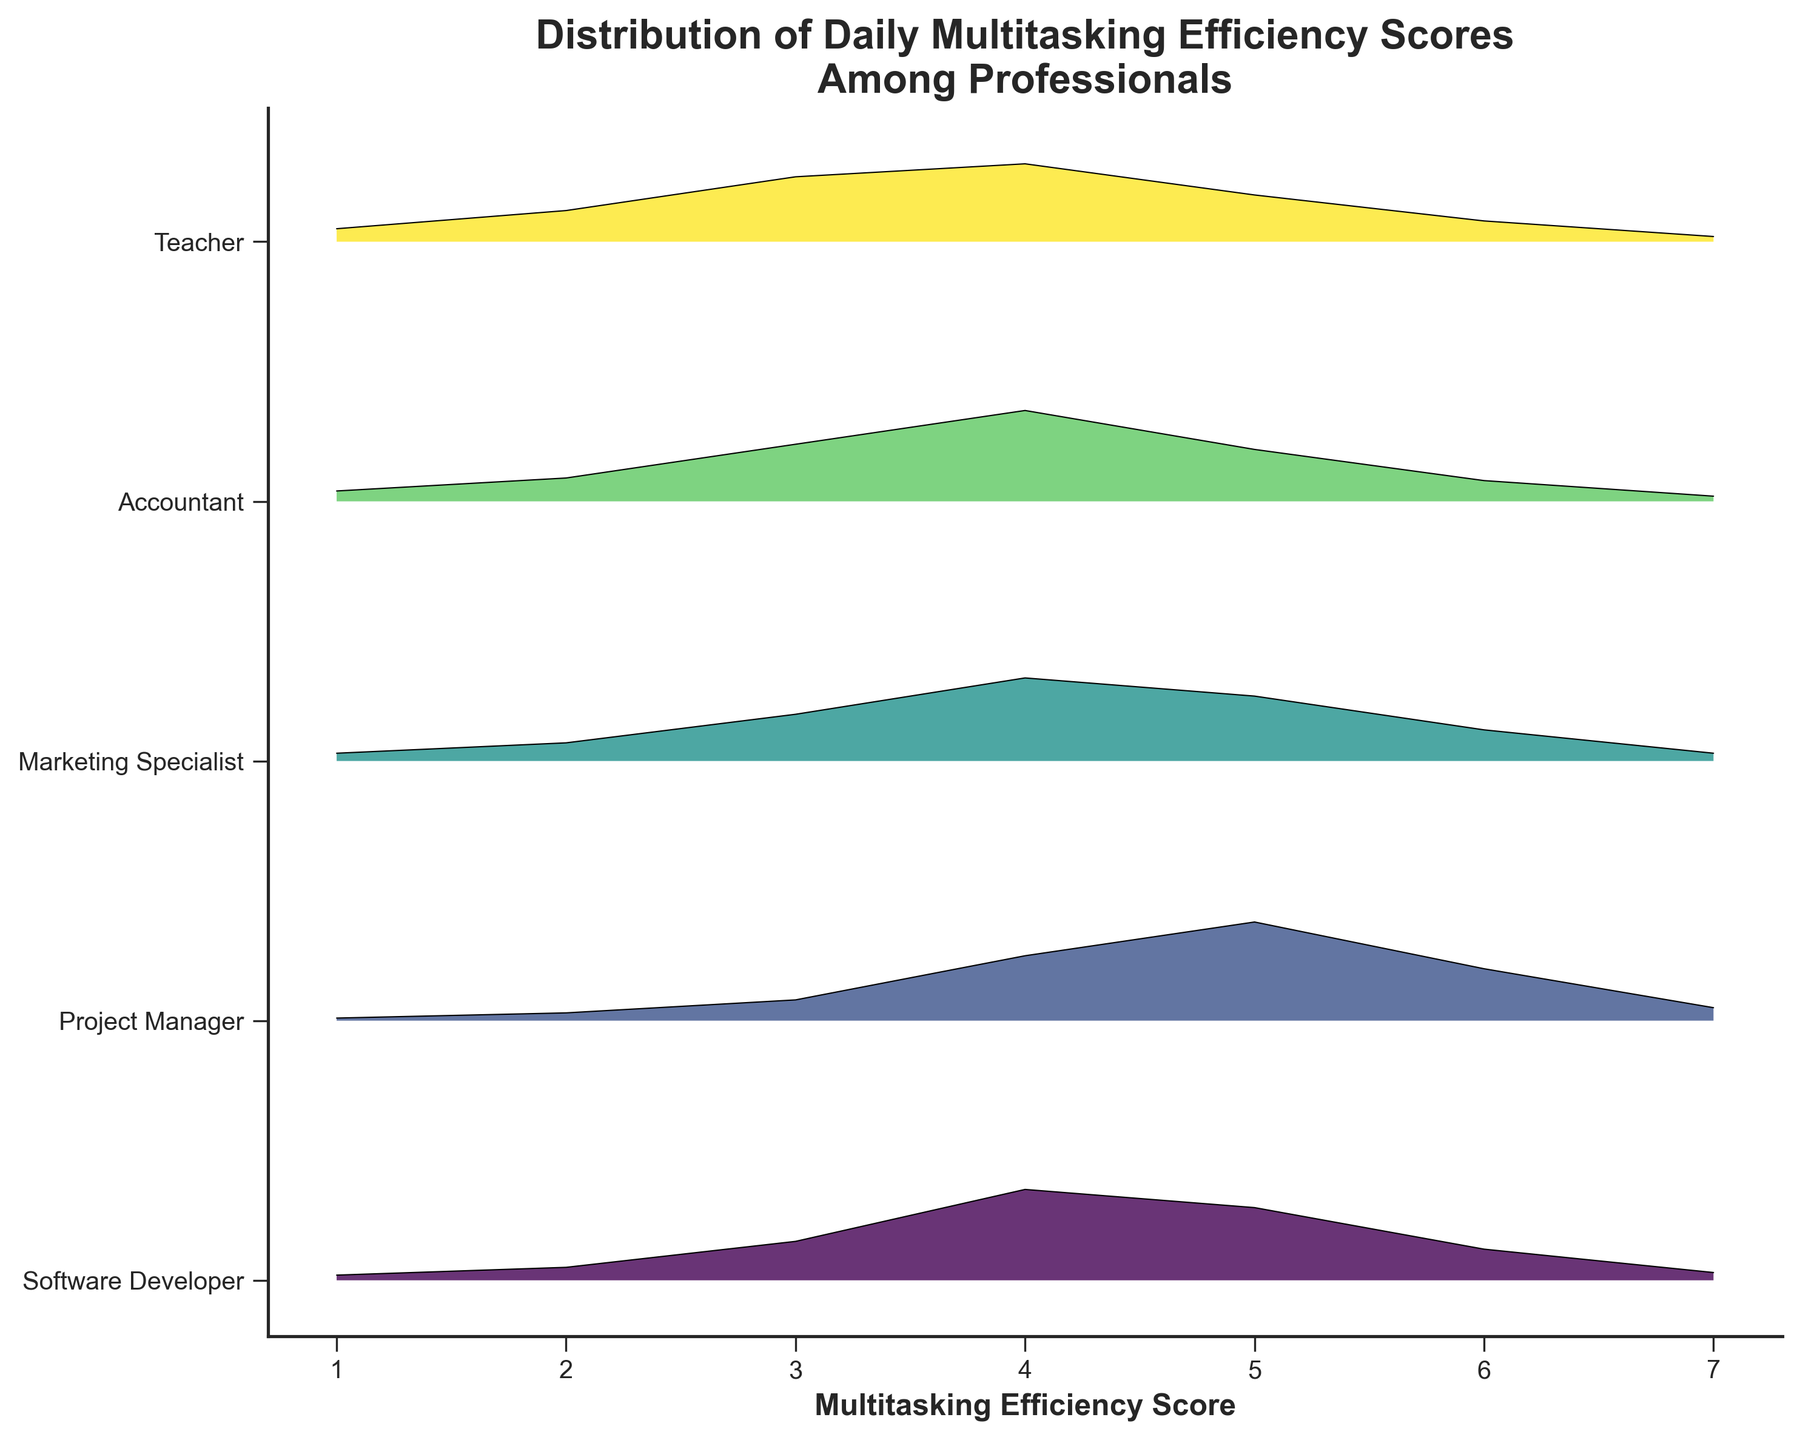What's the title of the plot? The title is located at the top of the plot and indicates what the figure is about. By reading the top area, we notice the text.
Answer: Distribution of Daily Multitasking Efficiency Scores Among Professionals What is on the x-axis of the plot? The x-axis typically shows what is being measured or the scores in this case. By looking at the label under the horizontal axis, we see the description.
Answer: Multitasking Efficiency Score How many professions are shown in the plot? By counting the distinct labels along the y-axis, we can determine the number of different professions included in the analysis.
Answer: 5 Which profession has the highest peak density in multitasking efficiency scores? To determine this, we look for the profession with the tallest peak in the plot, indicating the highest point of density.
Answer: Project Manager At which score do Teachers have their highest density? By locating the Teacher's profile in the plot and identifying the highest point of the ridgeline for that profile, we find the multitasking efficiency score corresponding to this peak.
Answer: 3 Which profession has the widest distribution of multitasking efficiency scores? To find this, we observe the spread of the peaks from the lowest to highest density points for each profession's ridgeline.
Answer: Teacher What is the common multitasking efficiency score interval with higher densities across most professions? By observing the density of all the ridgelines, identify the common score range where multiple professions exhibit higher densities.
Answer: 3 to 5 Which profession has the lowest peak density in multitasking efficiency scores? To determine this, we look for the profession with the shortest peak in the plot, indicating the lowest point of density.
Answer: Accountant At which scores do Software Developers have noticeable density peaks? By examining the Software Developer's profile on the plot, we identify the positions where the ridgeline significantly bulges out.
Answer: 3, 4, and 5 Compare the multitasking efficiency scores of Accountants and Marketing Specialists. Which profession shows a higher density at score 4? To compare, we locate the ridgelines for both professions at the score of 4 and evaluate which one has a larger bulge.
Answer: Accountant 